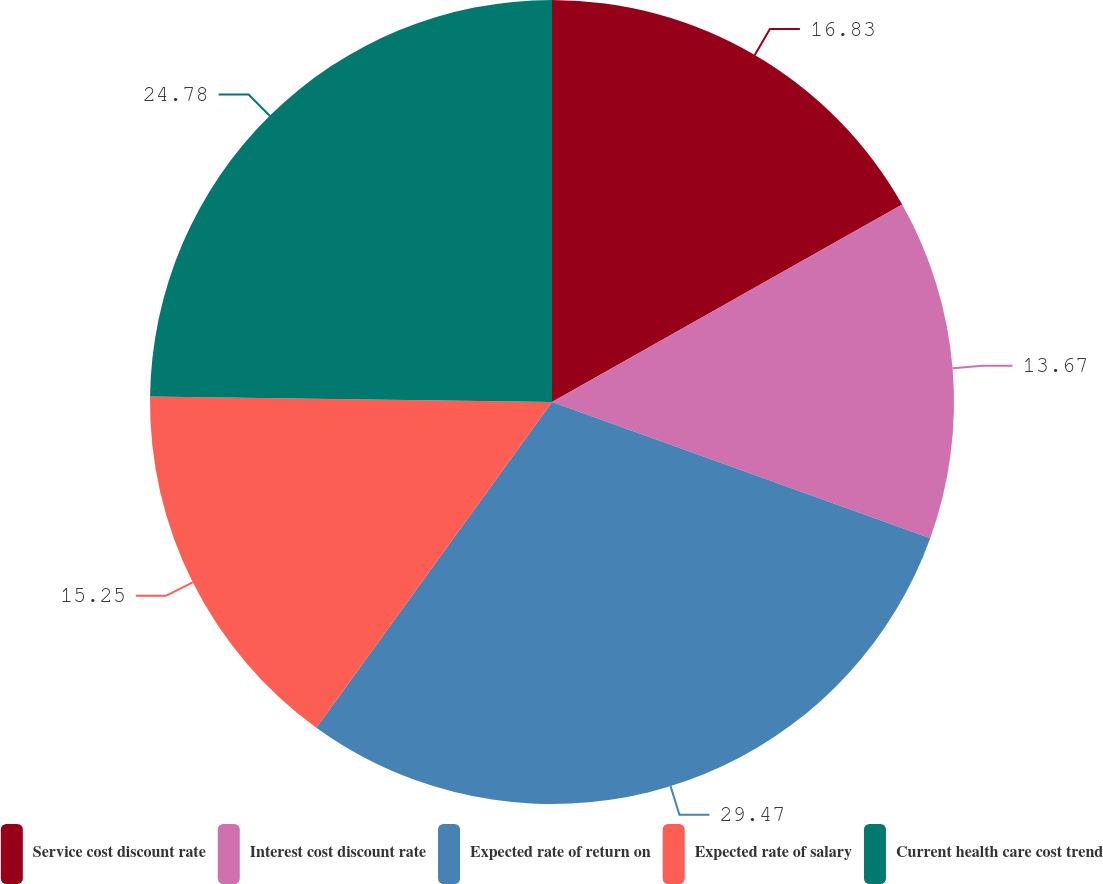Convert chart. <chart><loc_0><loc_0><loc_500><loc_500><pie_chart><fcel>Service cost discount rate<fcel>Interest cost discount rate<fcel>Expected rate of return on<fcel>Expected rate of salary<fcel>Current health care cost trend<nl><fcel>16.83%<fcel>13.67%<fcel>29.47%<fcel>15.25%<fcel>24.78%<nl></chart> 